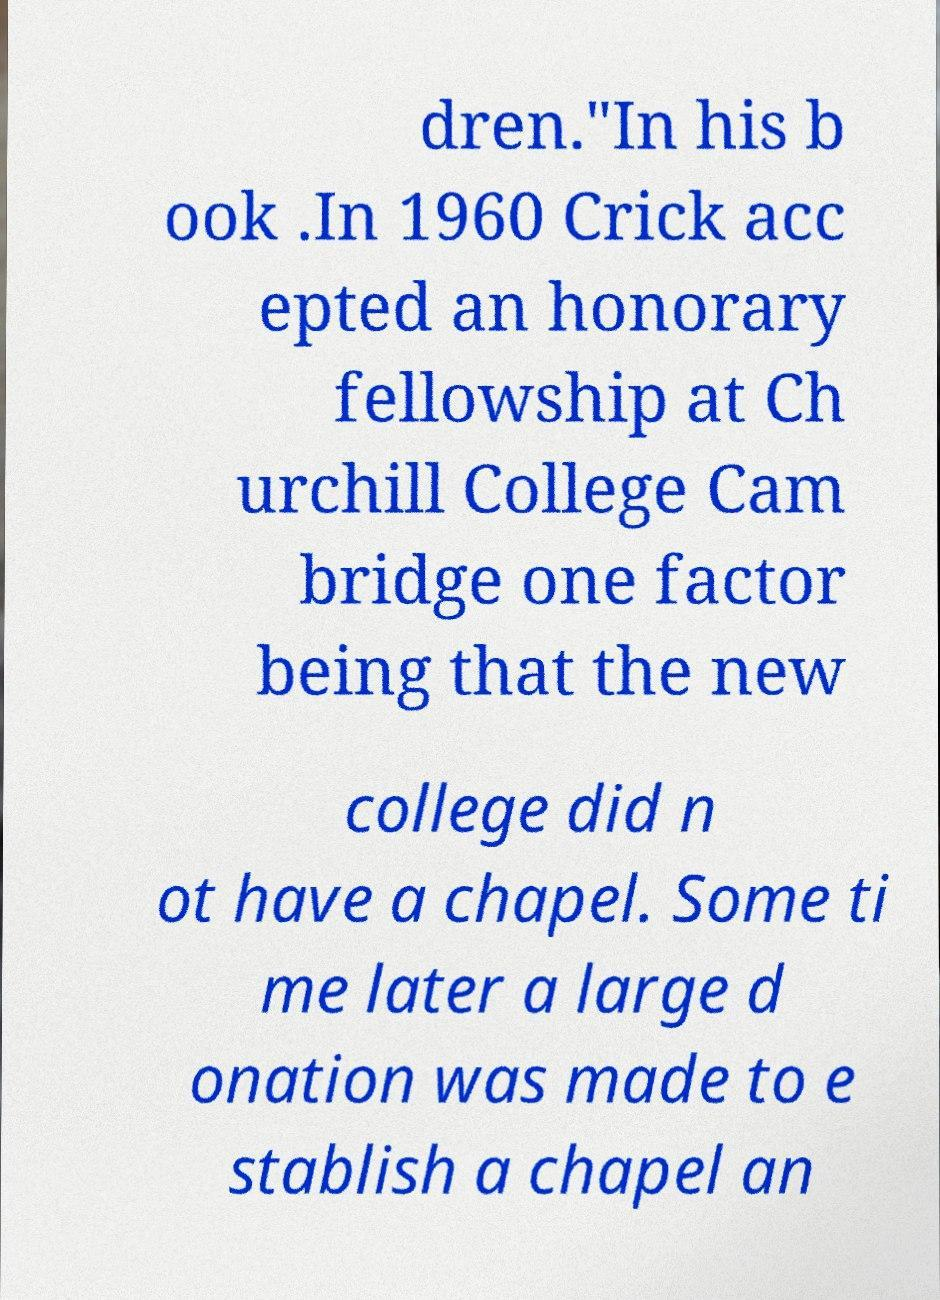Please identify and transcribe the text found in this image. dren."In his b ook .In 1960 Crick acc epted an honorary fellowship at Ch urchill College Cam bridge one factor being that the new college did n ot have a chapel. Some ti me later a large d onation was made to e stablish a chapel an 